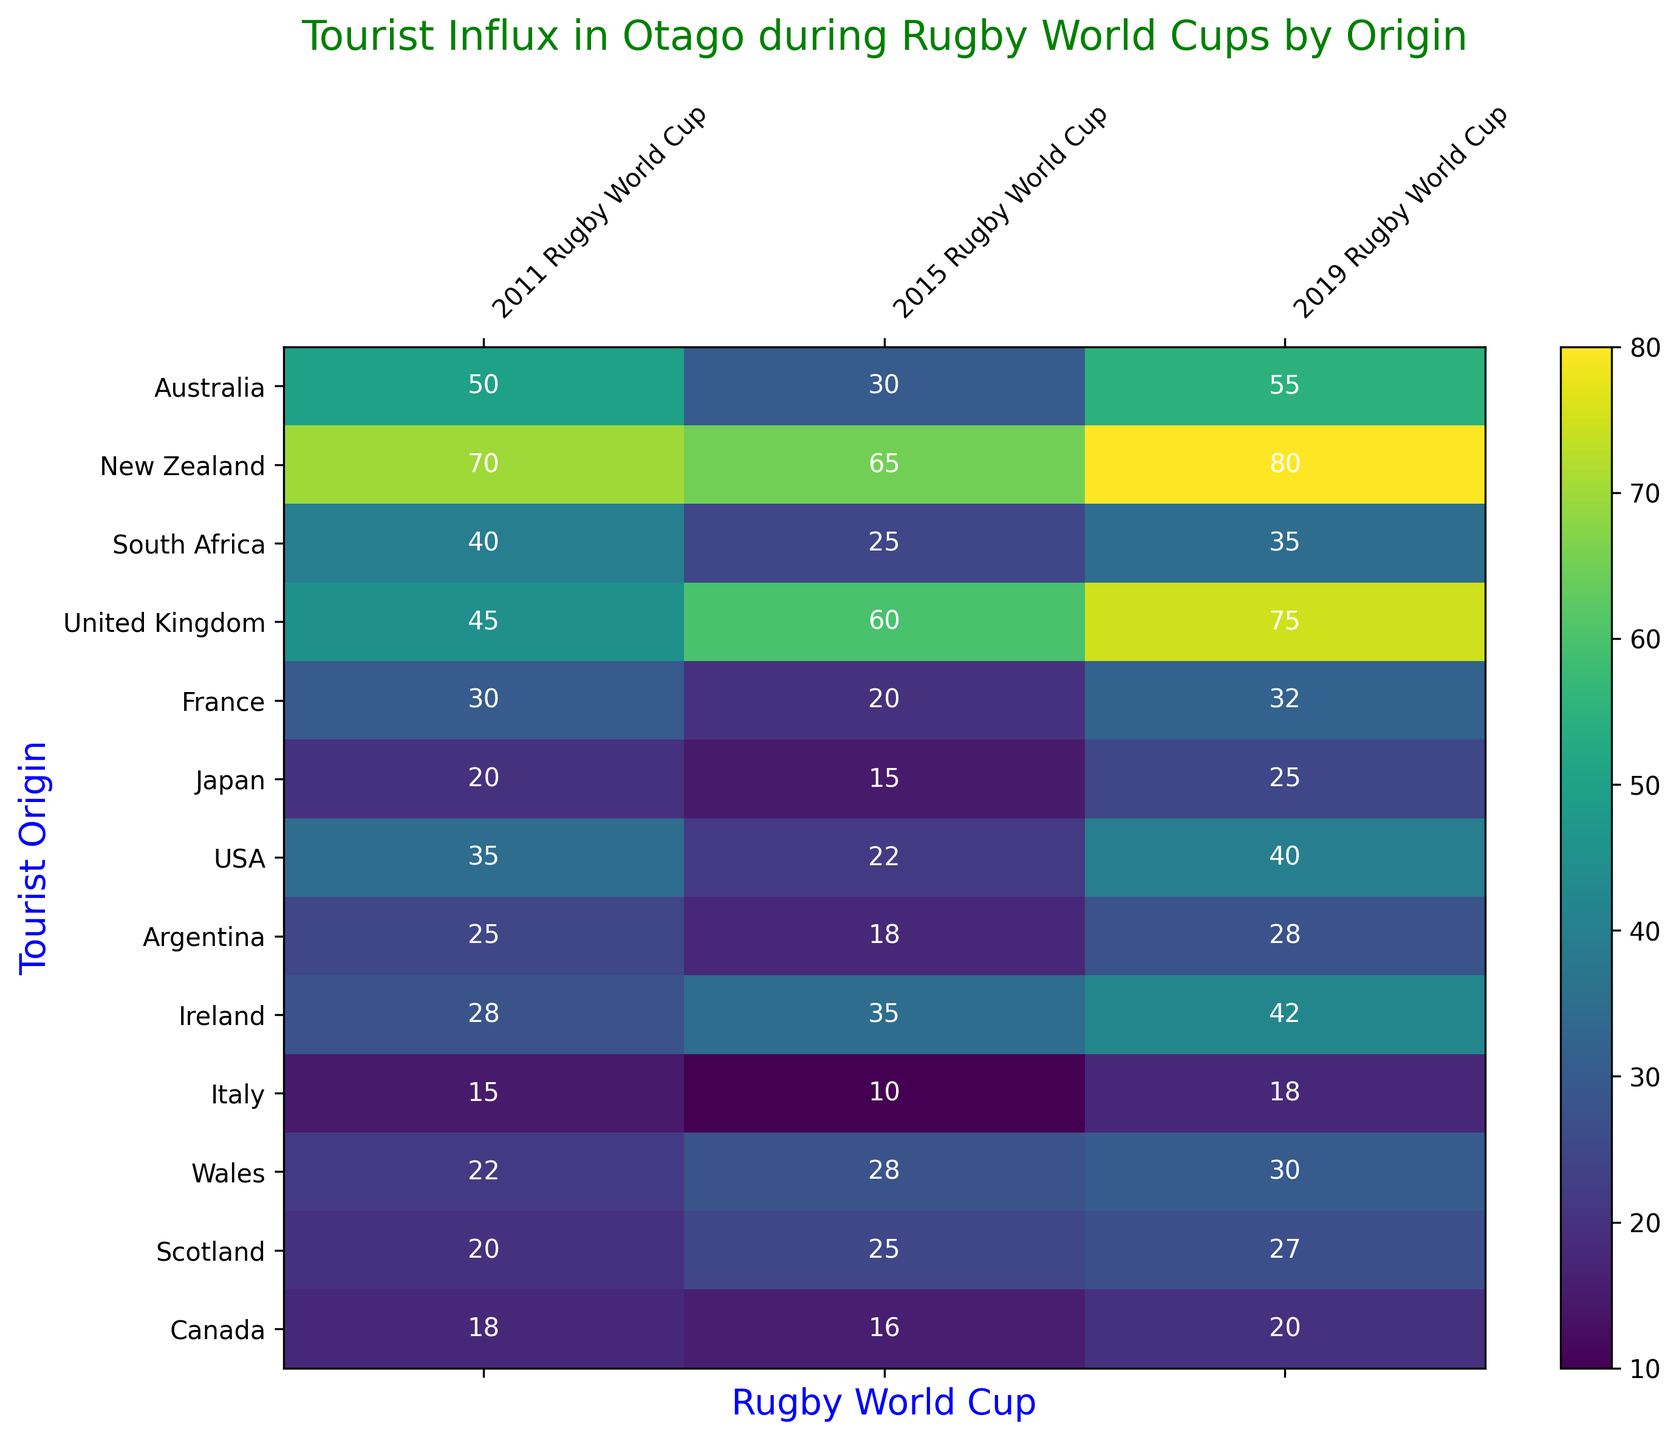What was the total tourist influx from New Zealand during all three Rugby World Cups? The influx values from New Zealand for the three events are 70, 65, and 80. Adding these numbers: 70 + 65 + 80 = 215.
Answer: 215 Which country saw the highest tourist influx during the 2019 Rugby World Cup? In the 2019 column, New Zealand had 80, which is the highest value compared to other countries.
Answer: New Zealand How did the tourist influx from Australia change from 2011 to 2019? The influx values for Australia are 50 in 2011, 30 in 2015, and 55 in 2019. From 2011 to 2015, it decreased by 20 (50 - 30). From 2015 to 2019, it increased by 25 (55 - 30).
Answer: Decreased by 20 and then increased by 25 Which country had the smallest increase in tourist influx from 2015 to 2019? The influx data for each country in 2015 and 2019 needs to be compared. Italy's influx increased from 10 to 18, which is an increase of 8, the smallest compared to other countries.
Answer: Italy What is the average tourist influx from France across the three Rugby World Cups? The influx values from France are 30, 20, and 32. The sum is 30 + 20 + 32 = 82. The average is 82/3 = 27.33.
Answer: 27.33 Which country had a similar tourist influx in 2011 and 2015? South Africa had 40 in 2011 and 25 in 2015, United Kingdom had 45 in 2011 and 60 in 2015, France had 30 in 2011 and 20 in 2015, Japan had 20 in 2011 and 15 in 2015, USA had 35 in 2011 and 22 in 2015. Australia had 50 in 2011 and 30 in 2015. New Zealand had 70 in 2011 and 65 in 2015. Scotland had 20 in 2011 and 25 in 2015. Canada had 18 in 2011 and 16 in 2015. Wales had 22 in 2011 and 28 in 2015. No country had exactly the same value, but Canada had the closest similar influx with 18 in 2011 and 16 in 2015.
Answer: Canada What is the combined tourist influx from the USA and Canada during the 2015 Rugby World Cup? The influx values for the USA and Canada in 2015 are 22 and 16 respectively. Adding these values together: 22 + 16 = 38.
Answer: 38 Which country showed the most significant decline in tourist influx from 2011 to 2015? The data shows the drop in tourist influx for each country between 2011 and 2015. South Africa's influx dropped from 40 to 25, a decline of 15, which is the most significant when compared with other countries.
Answer: South Africa What is the color shade representing the highest tourist influx in the heatmap? The highest tourist influx is represented by the value 80 from New Zealand in 2019 and is shown in the most intense color, which is the lightest shade of green to yellow.
Answer: Lightest shade of green/yellow Which origin had a consistent increase in tourist influx over the three World Cups? By checking each origin's values over the three years:
- New Zealand: 70, 65, 80 (Fluctuates)
- Australia: 50, 30, 55 (Fluctuates)
- South Africa: 40, 25, 35 (Fluctuates)
- United Kingdom: 45, 60, 75 (Increases)
- France: 30, 20, 32 (Fluctuates)
- Japan: 20, 15, 25 (Fluctuates)
- USA: 35, 22, 40 (Fluctuates)
- Argentina: 25, 18, 28 (Fluctuates)
- Ireland: 28, 35, 42 (Increases)
- Italy: 15, 10, 18 (Fluctuates)
- Wales: 22, 28, 30 (Increases)
- Scotland: 20, 25, 27 (Increases slightly)
- Canada: 18, 16, 20 (Fluctuates)
United Kingdom, Ireland, Wales, and Scotland show consistent increases but United Kingdom and Ireland have shown more significant increases compared to Wales and Scotland.
Answer: United Kingdom, Ireland 